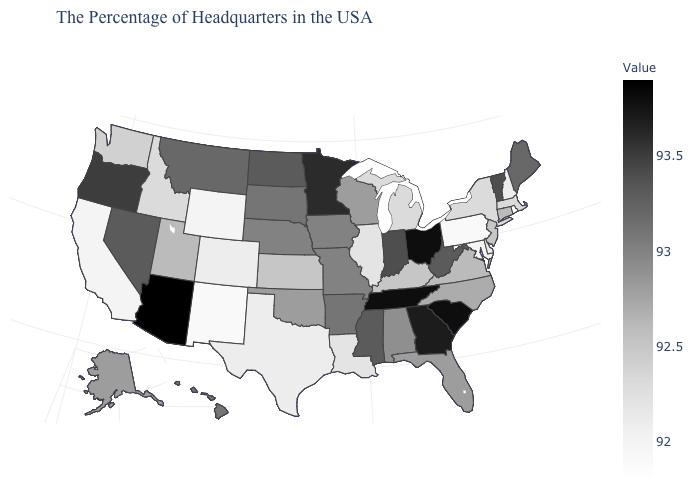Among the states that border Tennessee , which have the lowest value?
Write a very short answer. Kentucky. Which states hav the highest value in the West?
Write a very short answer. Arizona. Among the states that border South Carolina , which have the highest value?
Write a very short answer. Georgia. Which states have the highest value in the USA?
Give a very brief answer. Arizona. Does Indiana have a higher value than Georgia?
Answer briefly. No. Which states hav the highest value in the MidWest?
Answer briefly. Ohio. Among the states that border Louisiana , which have the highest value?
Quick response, please. Mississippi. 